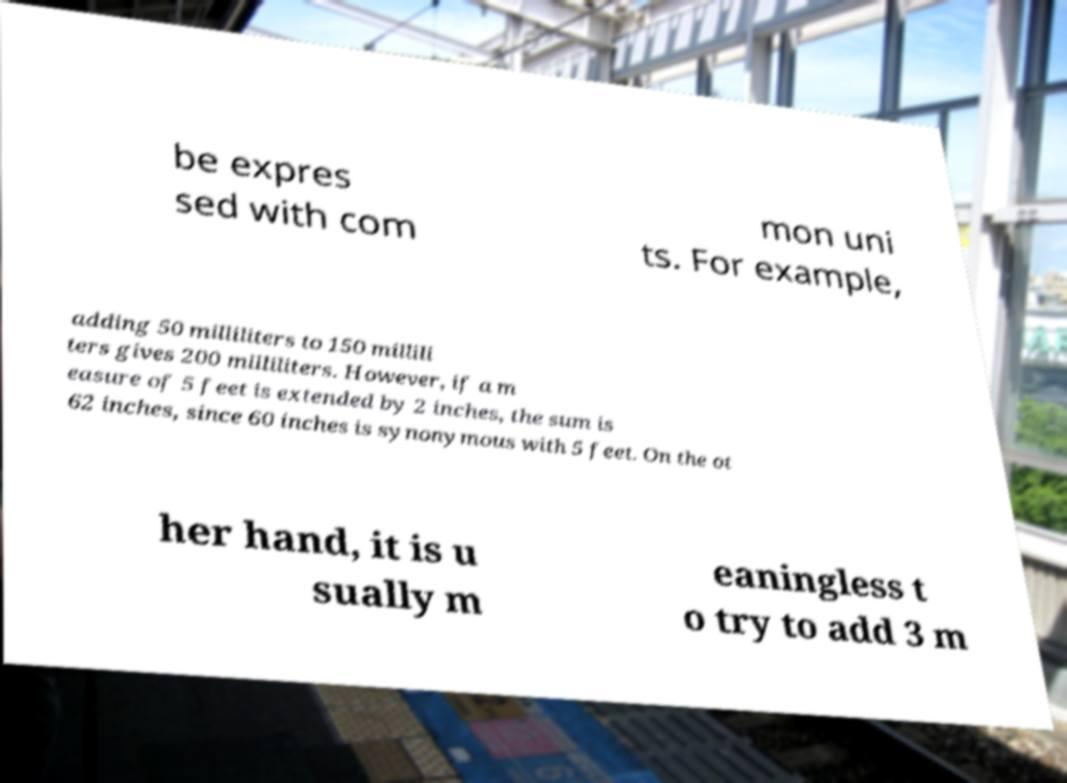Could you assist in decoding the text presented in this image and type it out clearly? be expres sed with com mon uni ts. For example, adding 50 milliliters to 150 millili ters gives 200 milliliters. However, if a m easure of 5 feet is extended by 2 inches, the sum is 62 inches, since 60 inches is synonymous with 5 feet. On the ot her hand, it is u sually m eaningless t o try to add 3 m 